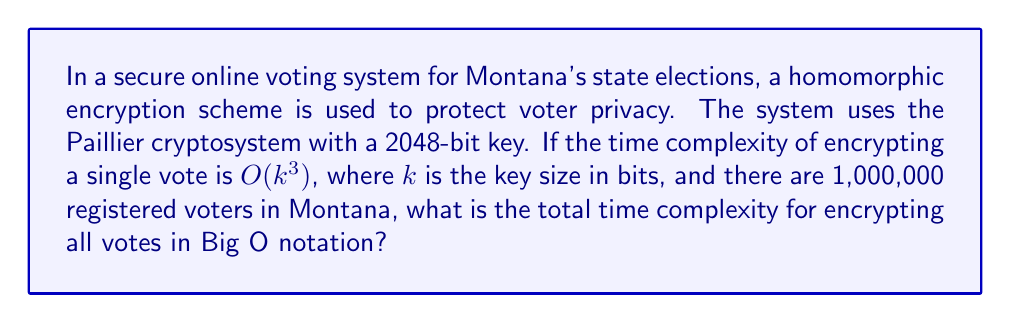Can you answer this question? To solve this problem, we need to follow these steps:

1. Understand the given information:
   - The Paillier cryptosystem is used with a 2048-bit key
   - The time complexity for encrypting a single vote is $O(k^3)$
   - There are 1,000,000 registered voters

2. Calculate the time complexity for a single vote encryption:
   - Key size $k = 2048$ bits
   - Time complexity for one vote = $O(k^3) = O(2048^3) = O(8,589,934,592)$

3. Calculate the total time complexity for all votes:
   - Number of voters = 1,000,000
   - Total time complexity = Time complexity for one vote × Number of voters
   - Total time complexity = $O(8,589,934,592) \times 1,000,000$

4. Simplify the result:
   - $O(8,589,934,592,000,000)$ can be written as $O(8.59 \times 10^{15})$

5. Express the final answer in Big O notation:
   - Since Big O notation represents the upper bound of the growth rate, we can simplify this to $O(10^{16})$

This result indicates that the total time complexity for encrypting all votes scales with the cube of the key size and linearly with the number of voters.
Answer: $O(10^{16})$ 